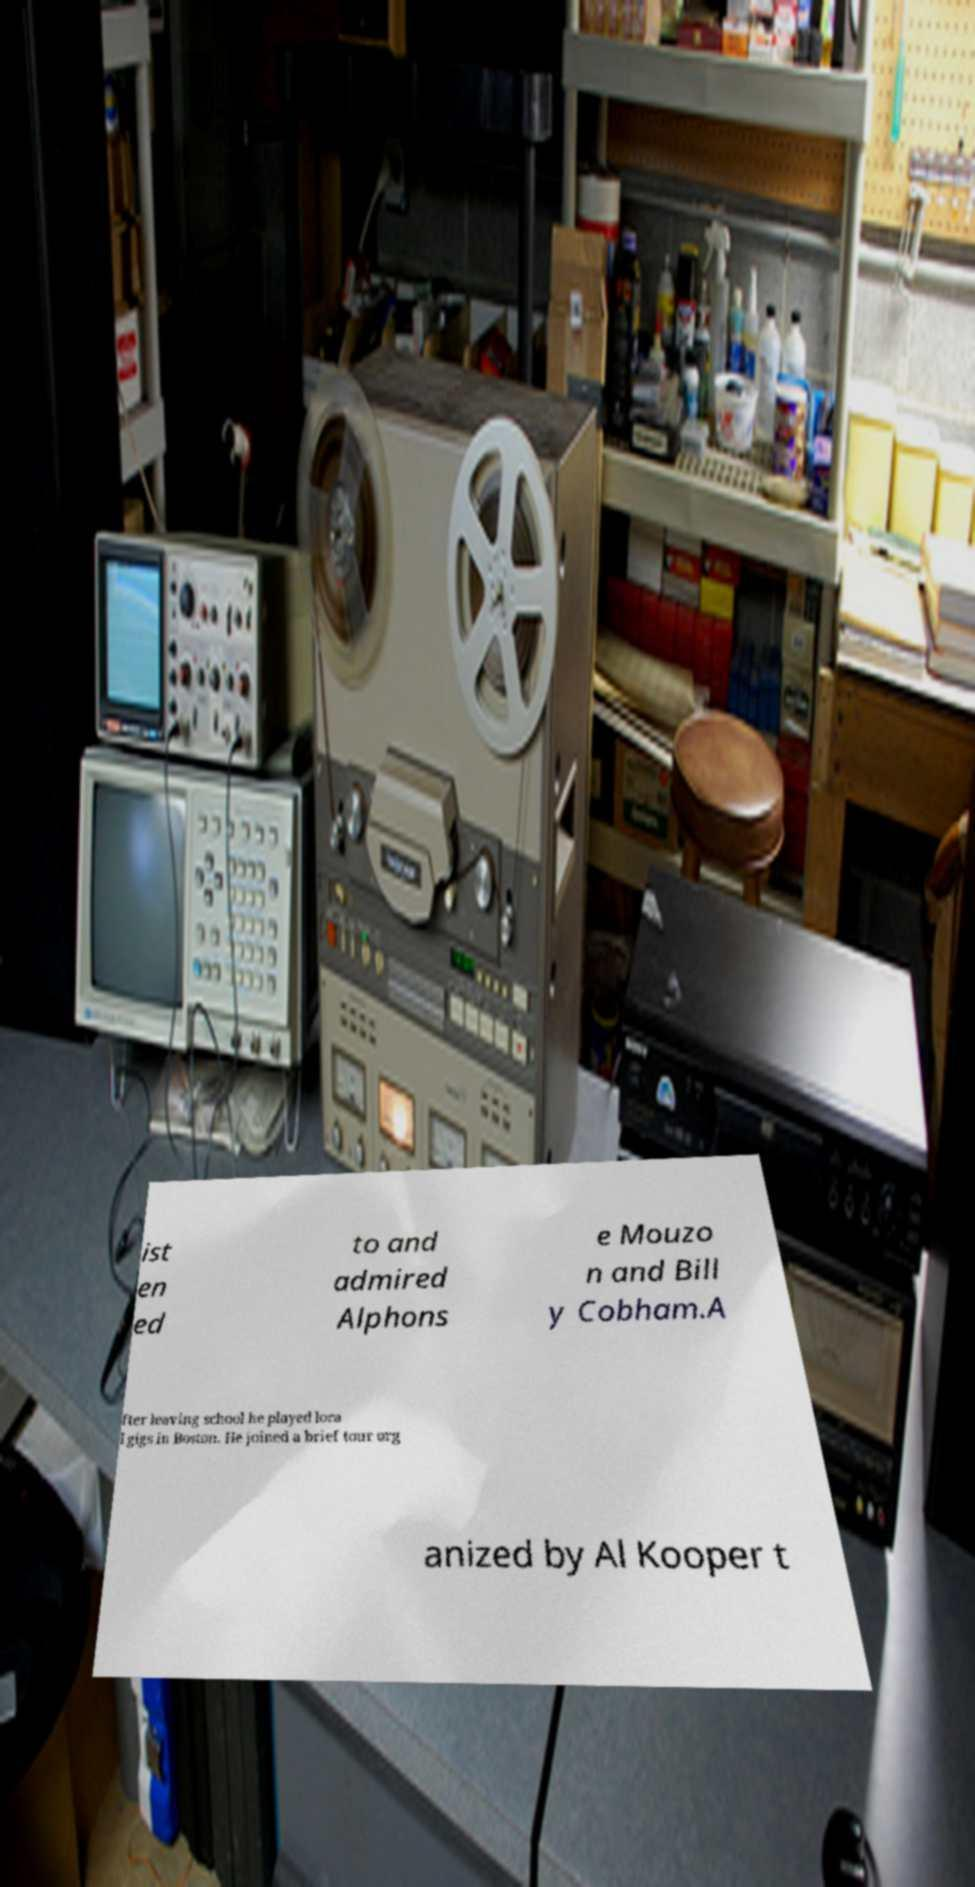I need the written content from this picture converted into text. Can you do that? ist en ed to and admired Alphons e Mouzo n and Bill y Cobham.A fter leaving school he played loca l gigs in Boston. He joined a brief tour org anized by Al Kooper t 